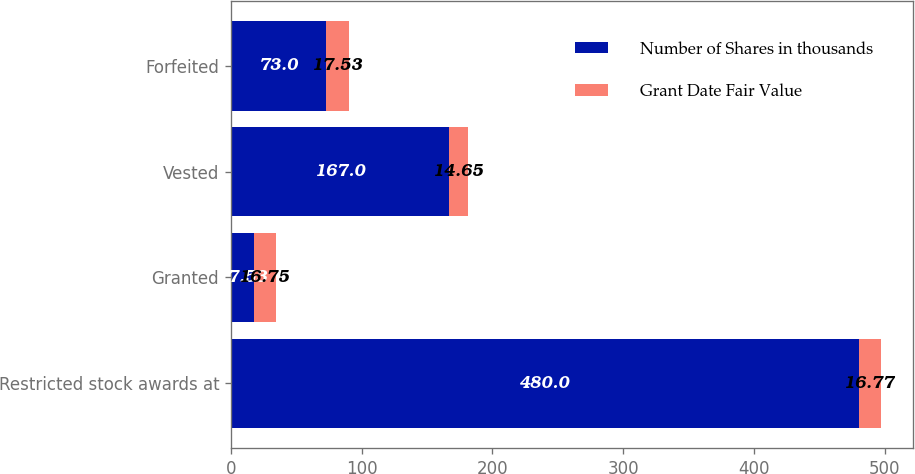Convert chart to OTSL. <chart><loc_0><loc_0><loc_500><loc_500><stacked_bar_chart><ecel><fcel>Restricted stock awards at<fcel>Granted<fcel>Vested<fcel>Forfeited<nl><fcel>Number of Shares in thousands<fcel>480<fcel>17.53<fcel>167<fcel>73<nl><fcel>Grant Date Fair Value<fcel>16.77<fcel>16.75<fcel>14.65<fcel>17.53<nl></chart> 